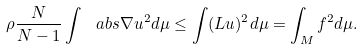Convert formula to latex. <formula><loc_0><loc_0><loc_500><loc_500>\rho \frac { N } { N - 1 } \int \ a b s { \nabla u } ^ { 2 } d \mu \leq \int ( L u ) ^ { 2 } d \mu = \int _ { M } f ^ { 2 } d \mu .</formula> 